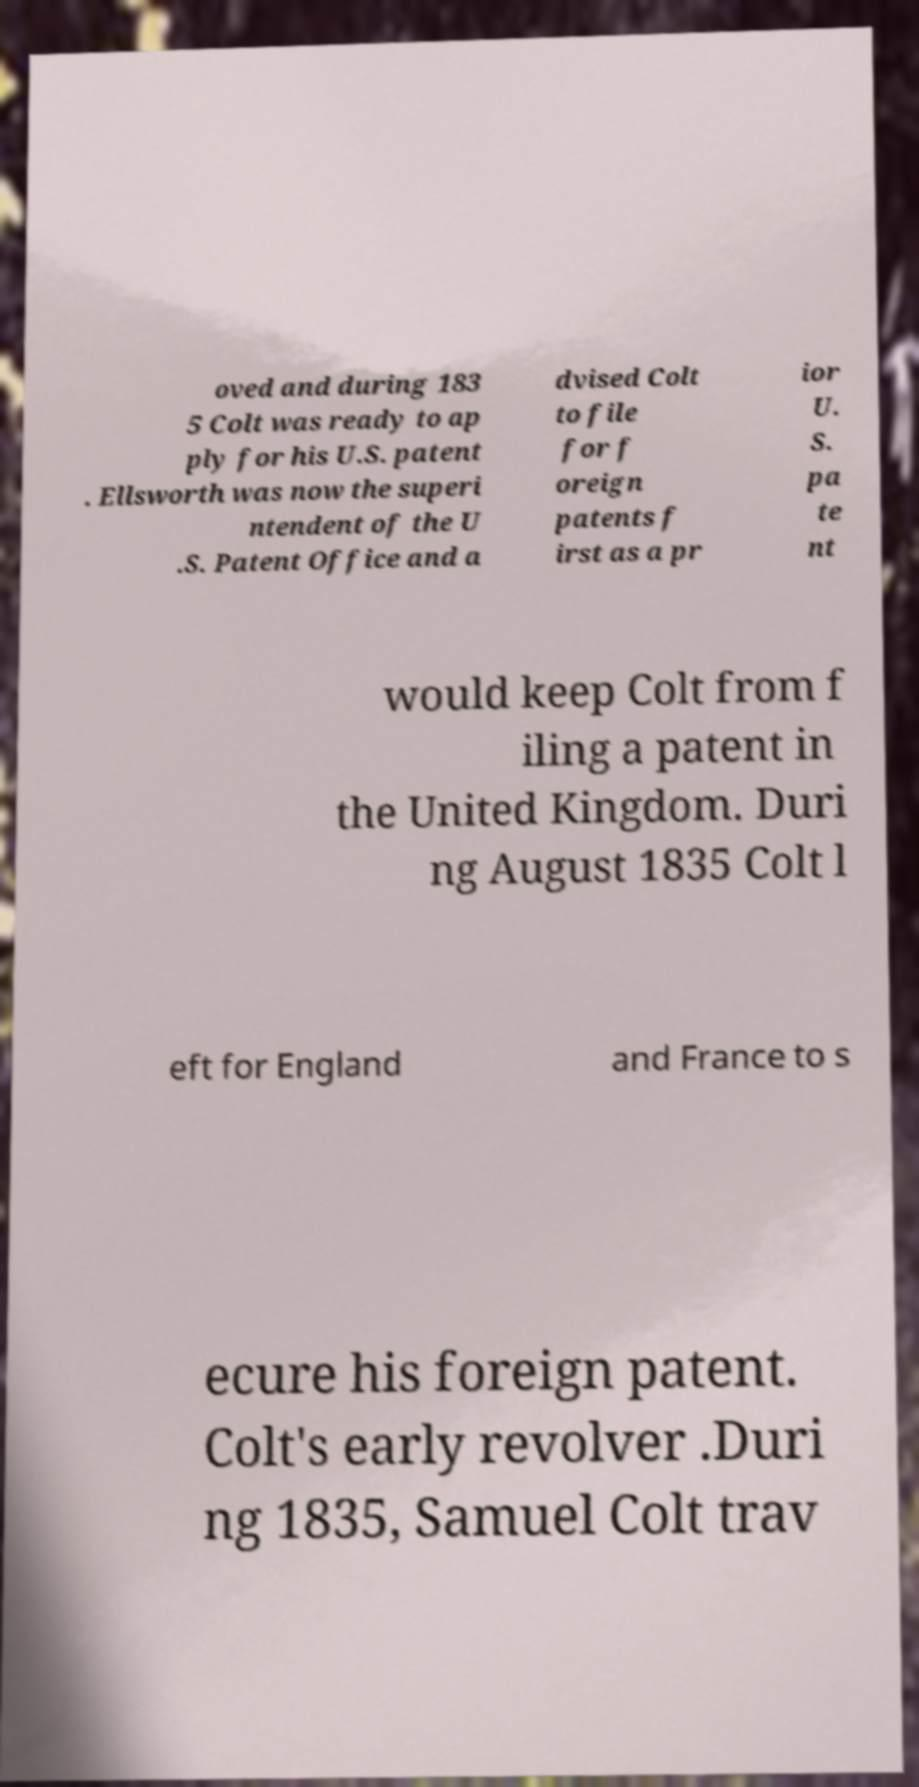What messages or text are displayed in this image? I need them in a readable, typed format. oved and during 183 5 Colt was ready to ap ply for his U.S. patent . Ellsworth was now the superi ntendent of the U .S. Patent Office and a dvised Colt to file for f oreign patents f irst as a pr ior U. S. pa te nt would keep Colt from f iling a patent in the United Kingdom. Duri ng August 1835 Colt l eft for England and France to s ecure his foreign patent. Colt's early revolver .Duri ng 1835, Samuel Colt trav 